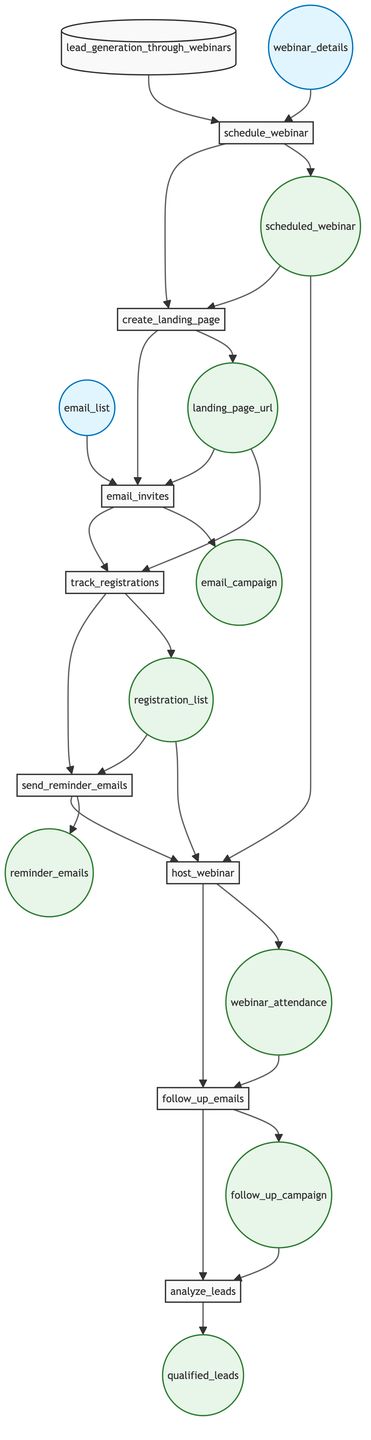What is the first action in the flowchart? The first action outlined in the flowchart is "schedule_webinar," as it is the first step in the lead generation process according to the diagram.
Answer: schedule_webinar How many output elements are shown in the diagram? By counting the distinct output elements that follow the action steps in the diagram, we find there are seven output elements: scheduled_webinar, landing_page_url, email_campaign, registration_list, reminder_emails, webinar_attendance, follow_up_campaign, and qualified_leads.
Answer: seven Which action follows "track_registrations"? The action that follows "track_registrations" in the flowchart is "send_reminder_emails," indicating the next step after tracking the registrations.
Answer: send_reminder_emails What inputs are required to send invitation emails? The inputs required to send invitation emails, as indicated in the diagram, are "email_list" and "landing_page_url." These inputs are necessary for this action to be successfully executed.
Answer: email_list, landing_page_url What are the final outputs of the function? The final outputs of the function, according to the flowchart, are "qualified_leads," which comes after all prior actions have been completed and leads analyzed in the last step of the process.
Answer: qualified_leads Which action depends on both scheduled_webinar and registration_list? The action that depends on both scheduled_webinar and registration_list is "host_webinar," as indicated by the flowchart that shows both inputs leading to this action's execution.
Answer: host_webinar How many main actions are there in total in the function? By examining the flowchart, there are eight main actions listed, each representing a step in the lead generation process through webinars.
Answer: eight What is the relationship between follow_up_emails and analyze_leads? The relationship between "follow_up_emails" and "analyze_leads" is sequential; "follow_up_emails" is the action taken before "analyze_leads," indicating that follow-up communication occurs prior to lead analysis.
Answer: sequential 